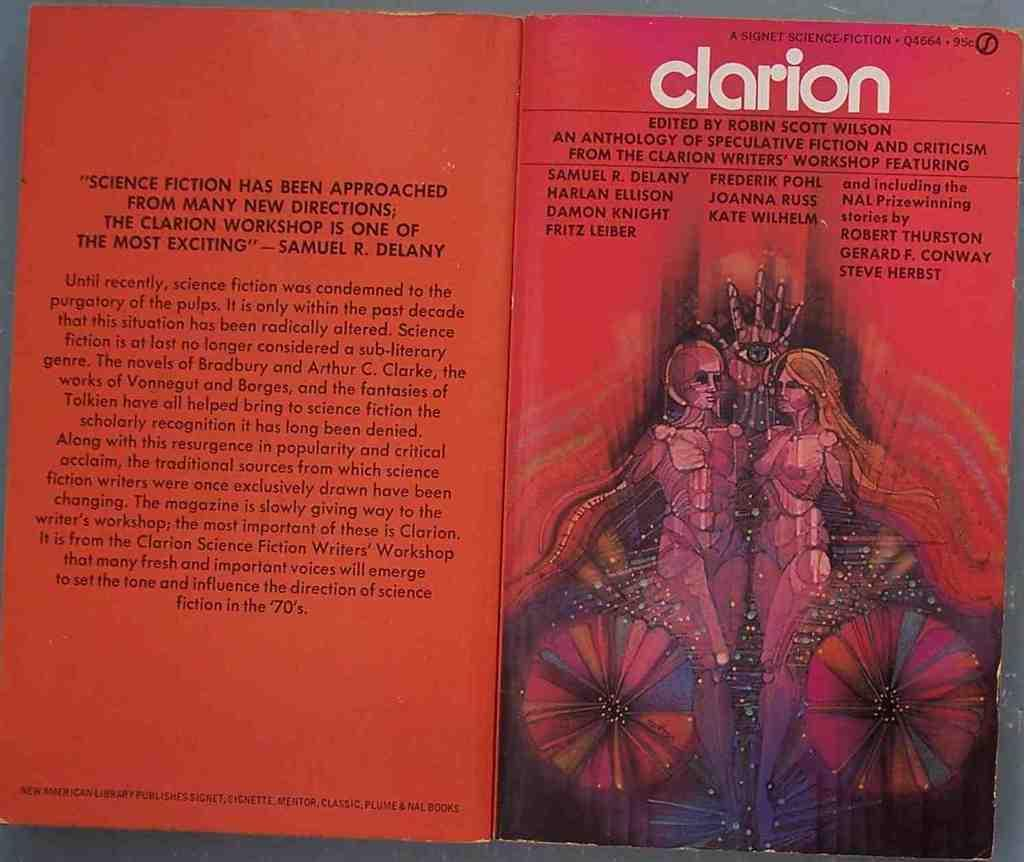<image>
Create a compact narrative representing the image presented. The front and back of a book called clarion 